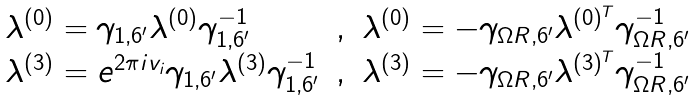Convert formula to latex. <formula><loc_0><loc_0><loc_500><loc_500>\begin{array} { l c l } \lambda ^ { ( 0 ) } = \gamma _ { 1 , 6 ^ { \prime } } \lambda ^ { ( 0 ) } \gamma _ { 1 , 6 ^ { \prime } } ^ { - 1 } & , & \lambda ^ { ( 0 ) } = - \gamma _ { \Omega R , 6 ^ { \prime } } \lambda ^ { ( 0 ) ^ { T } } \gamma _ { \Omega R , 6 ^ { \prime } } ^ { - 1 } \\ \lambda ^ { ( 3 ) } = e ^ { 2 \pi i v _ { i } } \gamma _ { 1 , 6 ^ { \prime } } \lambda ^ { ( 3 ) } \gamma _ { 1 , 6 ^ { \prime } } ^ { - 1 } & , & \lambda ^ { ( 3 ) } = - \gamma _ { \Omega R , 6 ^ { \prime } } \lambda ^ { ( 3 ) ^ { T } } \gamma _ { \Omega R , 6 ^ { \prime } } ^ { - 1 } \end{array}</formula> 